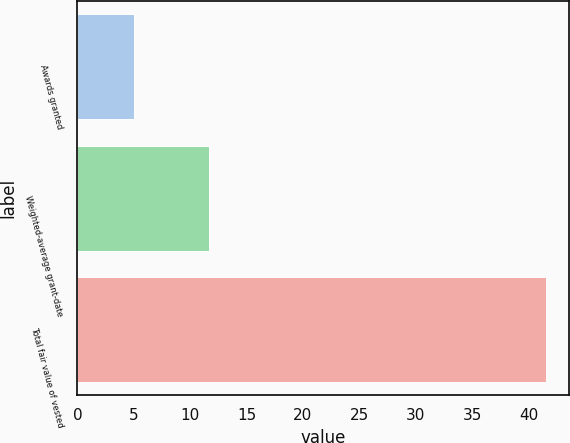Convert chart to OTSL. <chart><loc_0><loc_0><loc_500><loc_500><bar_chart><fcel>Awards granted<fcel>Weighted-average grant-date<fcel>Total fair value of vested<nl><fcel>5<fcel>11.68<fcel>41.5<nl></chart> 